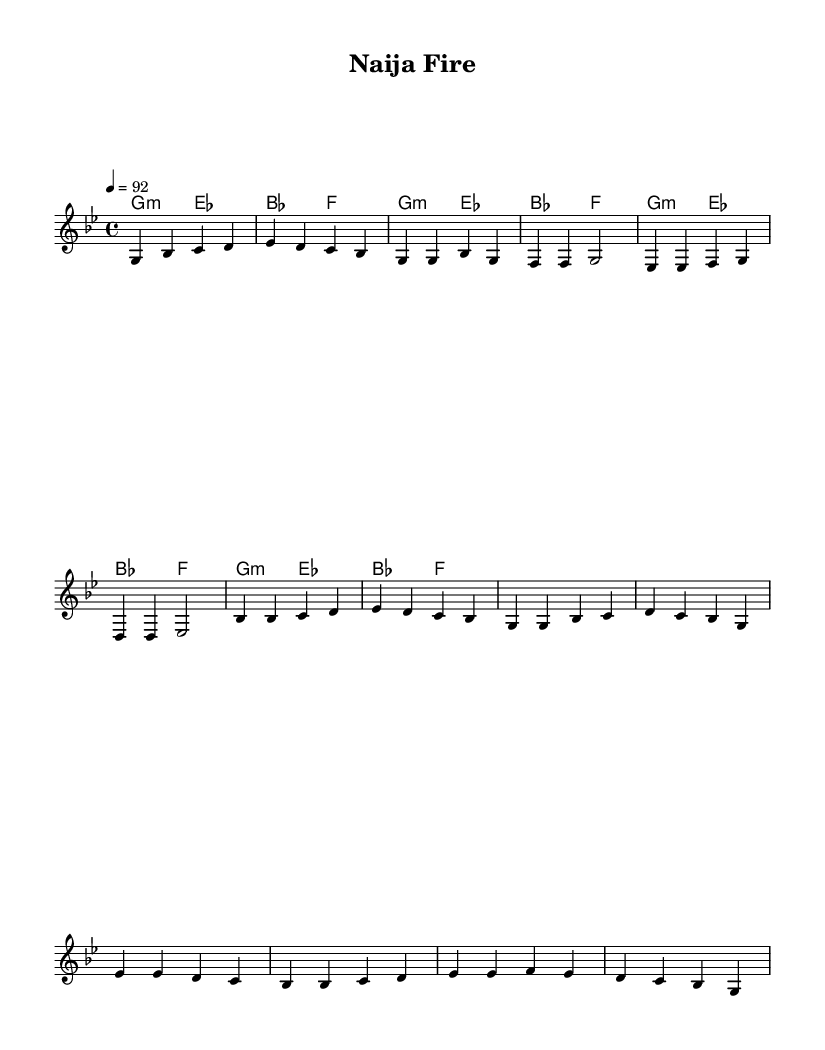What is the key signature of this music? The key signature is G minor, which has two flats: B-flat and E-flat. This can be determined by looking at the key indicated at the beginning of the score in the global section.
Answer: G minor What is the time signature of this music? The time signature is 4/4, which indicates that there are four beats per measure and the quarter note receives one beat. This is observed in the global section where the time is specified.
Answer: 4/4 What is the tempo marking for this piece? The tempo marking is 92 beats per minute, indicated by the number following the word 'tempo' in the global section.
Answer: 92 How many measures are there in the verse section? The verse section consists of four measures, which can be counted by examining the melody section from the start of the verse until the end.
Answer: 4 What type of harmonies are predominantly used in this piece? The harmonies used are primarily minor chords, specifically G minor and E-flat major, observed in the chord mode section where the chords are specified.
Answer: Minor Is there a distinct structure to this composition? Yes, the composition follows a common structure with an Intro, Verse, Chorus, and Bridge, suggesting a typical hip hop format of storytelling and motivational themes. This can be understood by looking at the sections labeled in the melody line.
Answer: Yes 